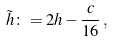Convert formula to latex. <formula><loc_0><loc_0><loc_500><loc_500>\tilde { h } \colon = 2 h - \frac { c } { 1 6 } \, ,</formula> 